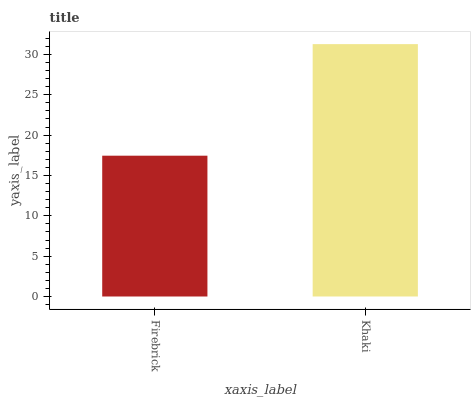Is Firebrick the minimum?
Answer yes or no. Yes. Is Khaki the maximum?
Answer yes or no. Yes. Is Khaki the minimum?
Answer yes or no. No. Is Khaki greater than Firebrick?
Answer yes or no. Yes. Is Firebrick less than Khaki?
Answer yes or no. Yes. Is Firebrick greater than Khaki?
Answer yes or no. No. Is Khaki less than Firebrick?
Answer yes or no. No. Is Khaki the high median?
Answer yes or no. Yes. Is Firebrick the low median?
Answer yes or no. Yes. Is Firebrick the high median?
Answer yes or no. No. Is Khaki the low median?
Answer yes or no. No. 